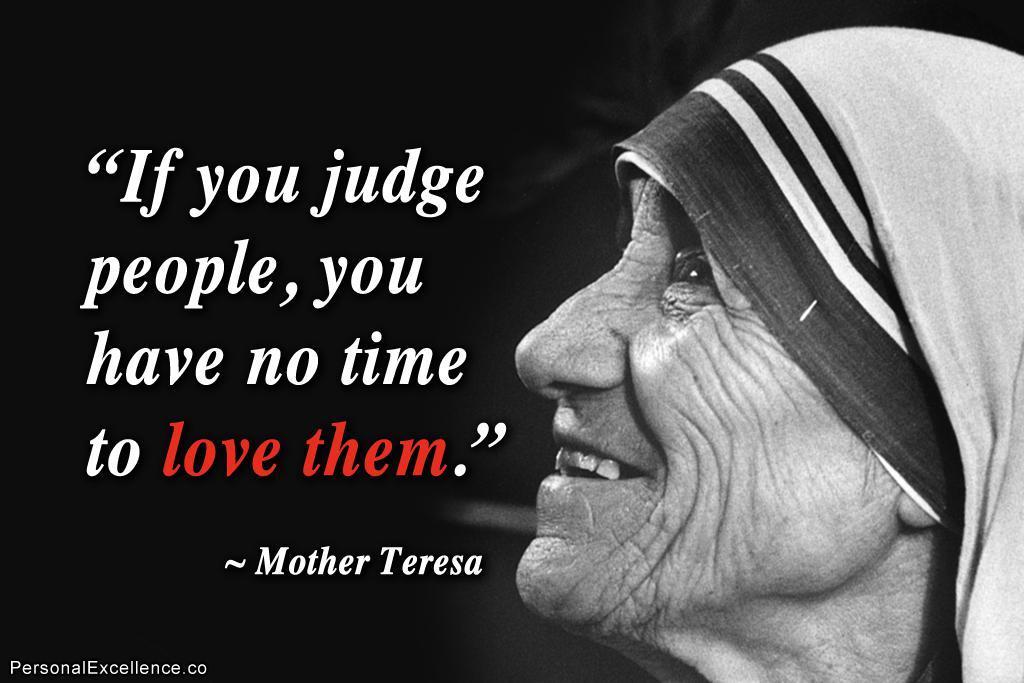Please provide a concise description of this image. In this image we can see a poster. On this poster we can see picture of a woman and text written on it. 